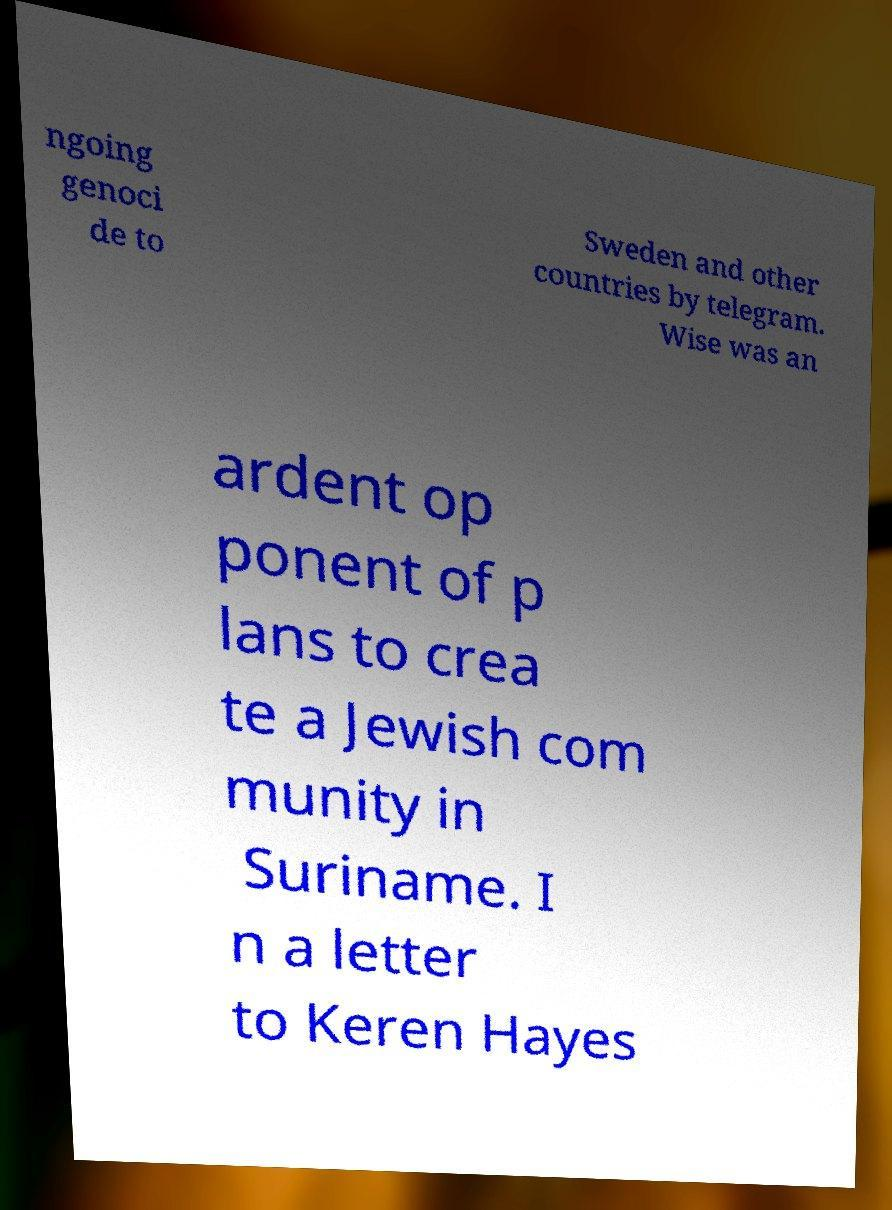What messages or text are displayed in this image? I need them in a readable, typed format. ngoing genoci de to Sweden and other countries by telegram. Wise was an ardent op ponent of p lans to crea te a Jewish com munity in Suriname. I n a letter to Keren Hayes 